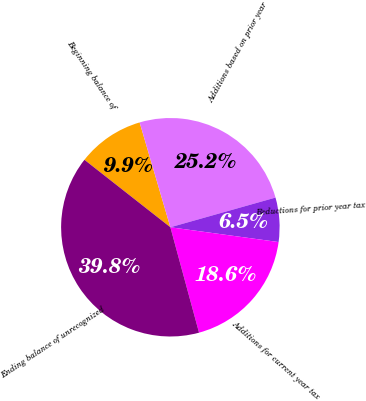Convert chart to OTSL. <chart><loc_0><loc_0><loc_500><loc_500><pie_chart><fcel>Beginning balance of<fcel>Additions based on prior year<fcel>Reductions for prior year tax<fcel>Additions for current year tax<fcel>Ending balance of unrecognized<nl><fcel>9.87%<fcel>25.16%<fcel>6.54%<fcel>18.61%<fcel>39.82%<nl></chart> 